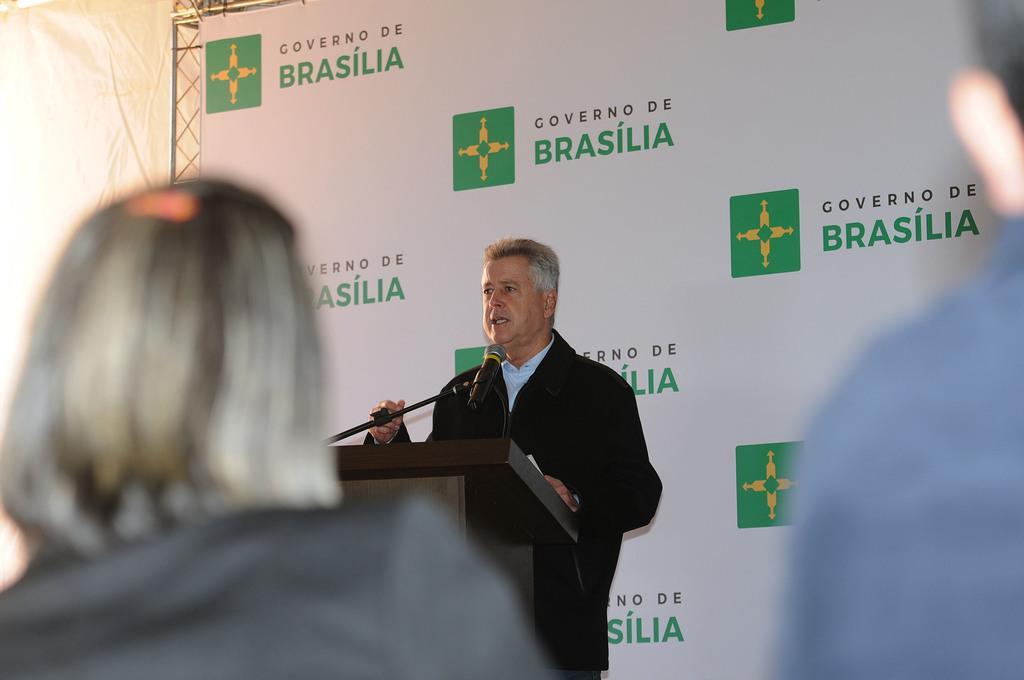How would you summarize this image in a sentence or two? This image is taken indoors. In the background there is a cloth which is white in color. There are a few iron bars and there is a banner with a text it. In the middle of the image a man is standing and talking. There is a podium with a mic. On the left side of the image there is a person and on the right side of the image there is a person. 